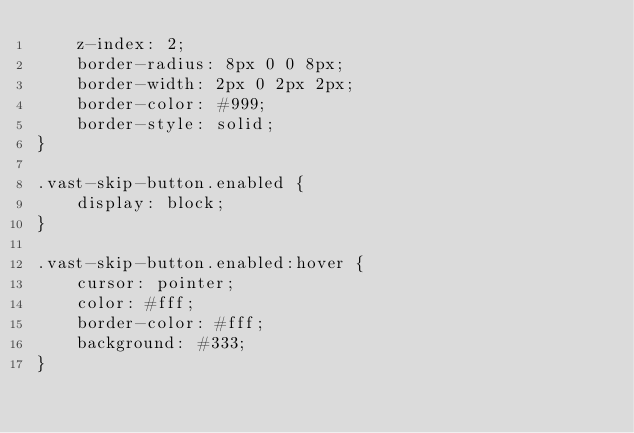<code> <loc_0><loc_0><loc_500><loc_500><_CSS_>    z-index: 2;
    border-radius: 8px 0 0 8px;
    border-width: 2px 0 2px 2px;
    border-color: #999;
    border-style: solid;
}

.vast-skip-button.enabled {
    display: block;
}

.vast-skip-button.enabled:hover {
    cursor: pointer;
    color: #fff;
    border-color: #fff;
    background: #333;
}
</code> 